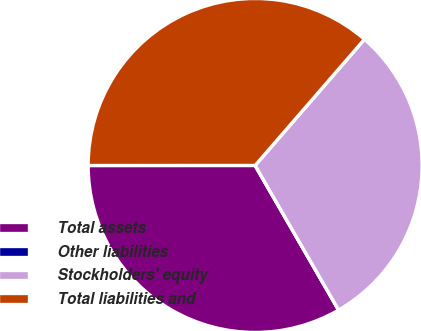Convert chart to OTSL. <chart><loc_0><loc_0><loc_500><loc_500><pie_chart><fcel>Total assets<fcel>Other liabilities<fcel>Stockholders' equity<fcel>Total liabilities and<nl><fcel>33.33%<fcel>0.0%<fcel>30.3%<fcel>36.37%<nl></chart> 